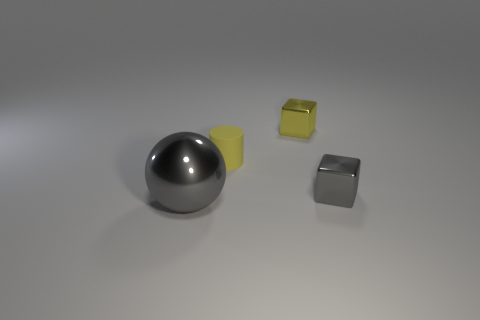What could be the purpose of these objects? The objects seem to be geometric shapes often used for various educational and design purposes. They can serve as visual aids in teaching geometry, as reference models in 3D design and computer graphics, or as part of a set of objects for still life paintings or photography. Their simplicity and clean lines also suggest they could be decorative elements in a minimalist setting. Could there be an artistic interpretation for them? Absolutely! Artistic interpretations could see these objects as a study of form, light, and shadow, highlighting the interplay between different shapes and the space they inhabit. They might represent the fundamental building blocks of visual composition, symbolizing balance, proportion, and the inherent beauty of geometry. 